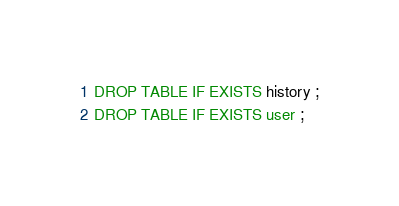<code> <loc_0><loc_0><loc_500><loc_500><_SQL_>DROP TABLE IF EXISTS history ;
DROP TABLE IF EXISTS user ;</code> 